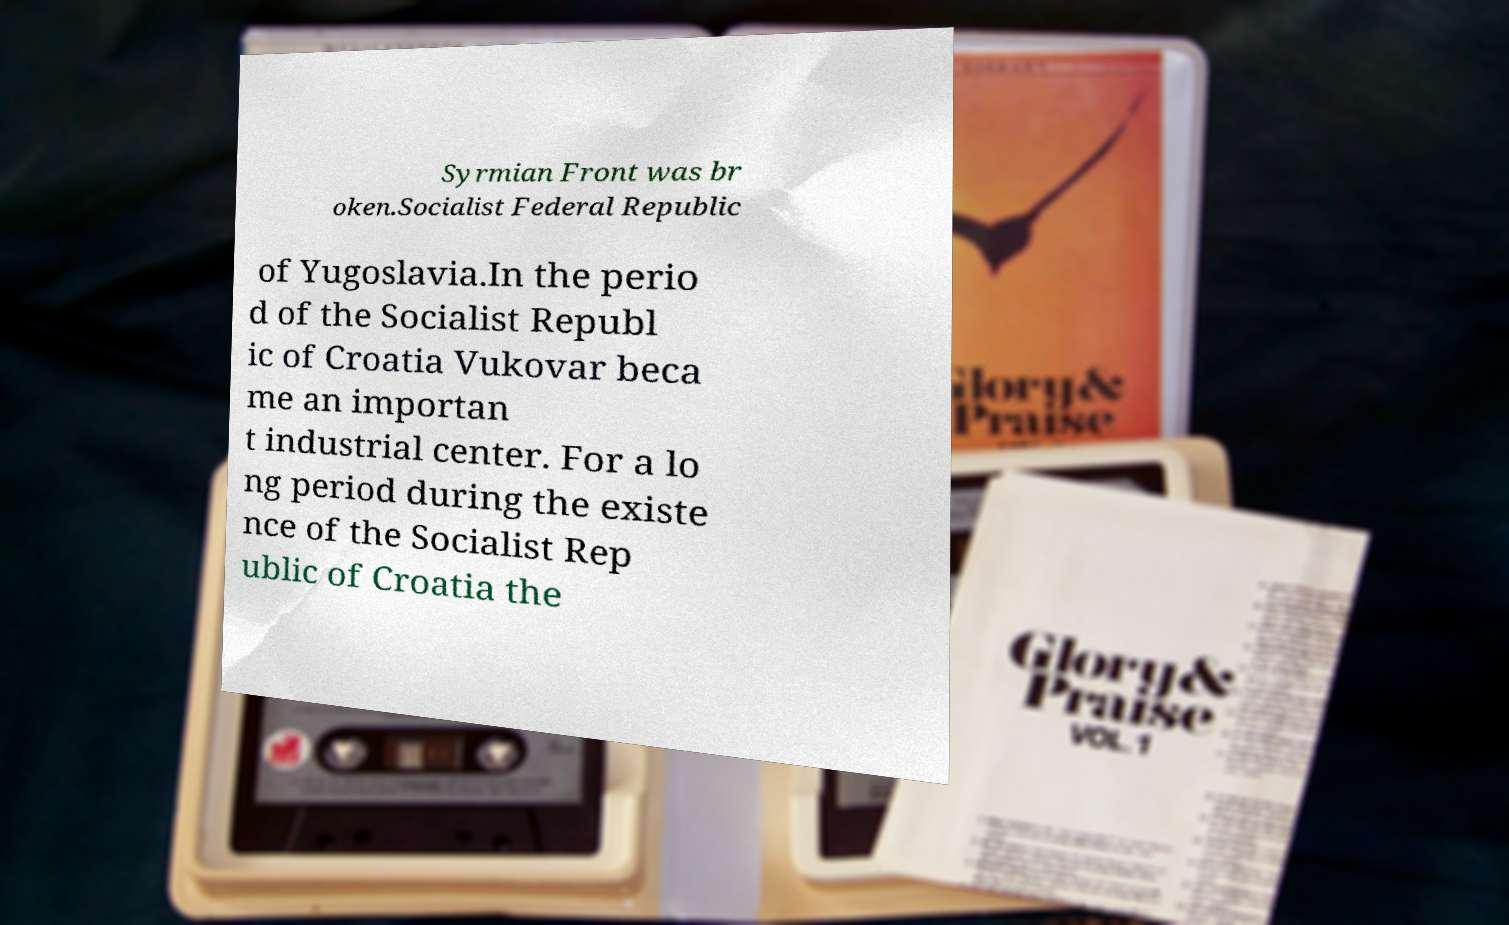I need the written content from this picture converted into text. Can you do that? Syrmian Front was br oken.Socialist Federal Republic of Yugoslavia.In the perio d of the Socialist Republ ic of Croatia Vukovar beca me an importan t industrial center. For a lo ng period during the existe nce of the Socialist Rep ublic of Croatia the 